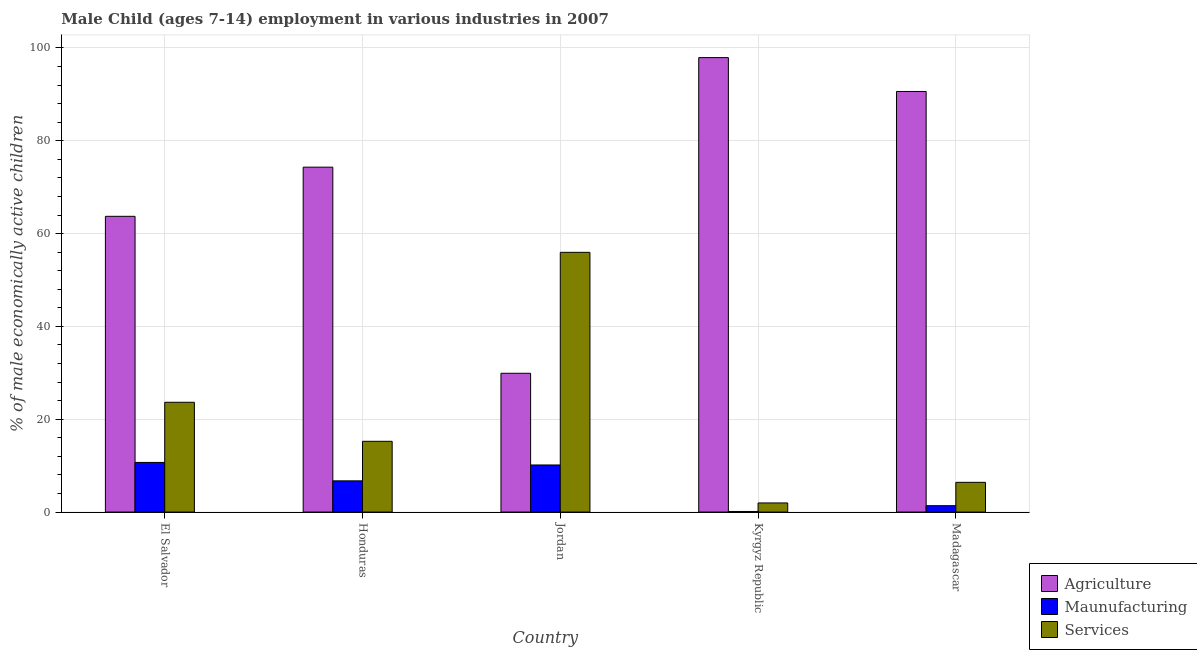How many different coloured bars are there?
Your answer should be very brief. 3. How many groups of bars are there?
Your response must be concise. 5. Are the number of bars per tick equal to the number of legend labels?
Provide a succinct answer. Yes. What is the label of the 5th group of bars from the left?
Your answer should be very brief. Madagascar. In how many cases, is the number of bars for a given country not equal to the number of legend labels?
Provide a succinct answer. 0. What is the percentage of economically active children in services in El Salvador?
Offer a terse response. 23.65. Across all countries, what is the maximum percentage of economically active children in agriculture?
Your answer should be very brief. 97.92. Across all countries, what is the minimum percentage of economically active children in agriculture?
Keep it short and to the point. 29.9. In which country was the percentage of economically active children in agriculture maximum?
Your answer should be compact. Kyrgyz Republic. In which country was the percentage of economically active children in agriculture minimum?
Offer a terse response. Jordan. What is the total percentage of economically active children in manufacturing in the graph?
Keep it short and to the point. 29.04. What is the difference between the percentage of economically active children in agriculture in Honduras and that in Jordan?
Ensure brevity in your answer.  44.41. What is the difference between the percentage of economically active children in manufacturing in Madagascar and the percentage of economically active children in agriculture in El Salvador?
Your answer should be very brief. -62.35. What is the average percentage of economically active children in services per country?
Offer a very short reply. 20.64. What is the difference between the percentage of economically active children in agriculture and percentage of economically active children in manufacturing in Jordan?
Provide a short and direct response. 19.76. In how many countries, is the percentage of economically active children in agriculture greater than 84 %?
Provide a succinct answer. 2. What is the ratio of the percentage of economically active children in manufacturing in El Salvador to that in Jordan?
Make the answer very short. 1.05. Is the percentage of economically active children in services in Jordan less than that in Kyrgyz Republic?
Your answer should be compact. No. Is the difference between the percentage of economically active children in agriculture in El Salvador and Jordan greater than the difference between the percentage of economically active children in services in El Salvador and Jordan?
Make the answer very short. Yes. What is the difference between the highest and the second highest percentage of economically active children in services?
Make the answer very short. 32.31. What is the difference between the highest and the lowest percentage of economically active children in manufacturing?
Offer a very short reply. 10.57. In how many countries, is the percentage of economically active children in services greater than the average percentage of economically active children in services taken over all countries?
Give a very brief answer. 2. What does the 1st bar from the left in El Salvador represents?
Your answer should be very brief. Agriculture. What does the 3rd bar from the right in Honduras represents?
Your answer should be very brief. Agriculture. Is it the case that in every country, the sum of the percentage of economically active children in agriculture and percentage of economically active children in manufacturing is greater than the percentage of economically active children in services?
Keep it short and to the point. No. Are the values on the major ticks of Y-axis written in scientific E-notation?
Ensure brevity in your answer.  No. Where does the legend appear in the graph?
Your answer should be very brief. Bottom right. How are the legend labels stacked?
Provide a short and direct response. Vertical. What is the title of the graph?
Your response must be concise. Male Child (ages 7-14) employment in various industries in 2007. Does "Machinery" appear as one of the legend labels in the graph?
Provide a succinct answer. No. What is the label or title of the X-axis?
Your answer should be compact. Country. What is the label or title of the Y-axis?
Offer a terse response. % of male economically active children. What is the % of male economically active children in Agriculture in El Salvador?
Your answer should be very brief. 63.72. What is the % of male economically active children of Maunufacturing in El Salvador?
Make the answer very short. 10.69. What is the % of male economically active children of Services in El Salvador?
Offer a terse response. 23.65. What is the % of male economically active children in Agriculture in Honduras?
Ensure brevity in your answer.  74.31. What is the % of male economically active children in Maunufacturing in Honduras?
Provide a short and direct response. 6.72. What is the % of male economically active children in Services in Honduras?
Ensure brevity in your answer.  15.24. What is the % of male economically active children of Agriculture in Jordan?
Your answer should be very brief. 29.9. What is the % of male economically active children of Maunufacturing in Jordan?
Make the answer very short. 10.14. What is the % of male economically active children in Services in Jordan?
Make the answer very short. 55.96. What is the % of male economically active children in Agriculture in Kyrgyz Republic?
Provide a short and direct response. 97.92. What is the % of male economically active children in Maunufacturing in Kyrgyz Republic?
Offer a terse response. 0.12. What is the % of male economically active children of Services in Kyrgyz Republic?
Provide a succinct answer. 1.96. What is the % of male economically active children of Agriculture in Madagascar?
Give a very brief answer. 90.62. What is the % of male economically active children of Maunufacturing in Madagascar?
Your response must be concise. 1.37. What is the % of male economically active children in Services in Madagascar?
Your response must be concise. 6.4. Across all countries, what is the maximum % of male economically active children of Agriculture?
Provide a short and direct response. 97.92. Across all countries, what is the maximum % of male economically active children in Maunufacturing?
Your response must be concise. 10.69. Across all countries, what is the maximum % of male economically active children of Services?
Make the answer very short. 55.96. Across all countries, what is the minimum % of male economically active children in Agriculture?
Keep it short and to the point. 29.9. Across all countries, what is the minimum % of male economically active children of Maunufacturing?
Your answer should be very brief. 0.12. Across all countries, what is the minimum % of male economically active children of Services?
Your answer should be compact. 1.96. What is the total % of male economically active children in Agriculture in the graph?
Give a very brief answer. 356.47. What is the total % of male economically active children of Maunufacturing in the graph?
Provide a short and direct response. 29.04. What is the total % of male economically active children of Services in the graph?
Keep it short and to the point. 103.21. What is the difference between the % of male economically active children of Agriculture in El Salvador and that in Honduras?
Offer a terse response. -10.59. What is the difference between the % of male economically active children in Maunufacturing in El Salvador and that in Honduras?
Give a very brief answer. 3.97. What is the difference between the % of male economically active children of Services in El Salvador and that in Honduras?
Offer a very short reply. 8.41. What is the difference between the % of male economically active children in Agriculture in El Salvador and that in Jordan?
Your answer should be compact. 33.82. What is the difference between the % of male economically active children of Maunufacturing in El Salvador and that in Jordan?
Your answer should be compact. 0.55. What is the difference between the % of male economically active children in Services in El Salvador and that in Jordan?
Your answer should be compact. -32.31. What is the difference between the % of male economically active children of Agriculture in El Salvador and that in Kyrgyz Republic?
Your answer should be very brief. -34.2. What is the difference between the % of male economically active children of Maunufacturing in El Salvador and that in Kyrgyz Republic?
Your answer should be very brief. 10.57. What is the difference between the % of male economically active children of Services in El Salvador and that in Kyrgyz Republic?
Offer a terse response. 21.69. What is the difference between the % of male economically active children of Agriculture in El Salvador and that in Madagascar?
Your response must be concise. -26.9. What is the difference between the % of male economically active children in Maunufacturing in El Salvador and that in Madagascar?
Give a very brief answer. 9.32. What is the difference between the % of male economically active children of Services in El Salvador and that in Madagascar?
Keep it short and to the point. 17.25. What is the difference between the % of male economically active children of Agriculture in Honduras and that in Jordan?
Your answer should be compact. 44.41. What is the difference between the % of male economically active children of Maunufacturing in Honduras and that in Jordan?
Give a very brief answer. -3.42. What is the difference between the % of male economically active children of Services in Honduras and that in Jordan?
Your answer should be very brief. -40.72. What is the difference between the % of male economically active children of Agriculture in Honduras and that in Kyrgyz Republic?
Give a very brief answer. -23.61. What is the difference between the % of male economically active children of Maunufacturing in Honduras and that in Kyrgyz Republic?
Give a very brief answer. 6.6. What is the difference between the % of male economically active children of Services in Honduras and that in Kyrgyz Republic?
Your answer should be compact. 13.28. What is the difference between the % of male economically active children of Agriculture in Honduras and that in Madagascar?
Ensure brevity in your answer.  -16.31. What is the difference between the % of male economically active children in Maunufacturing in Honduras and that in Madagascar?
Keep it short and to the point. 5.35. What is the difference between the % of male economically active children of Services in Honduras and that in Madagascar?
Ensure brevity in your answer.  8.84. What is the difference between the % of male economically active children of Agriculture in Jordan and that in Kyrgyz Republic?
Give a very brief answer. -68.02. What is the difference between the % of male economically active children in Maunufacturing in Jordan and that in Kyrgyz Republic?
Offer a very short reply. 10.02. What is the difference between the % of male economically active children of Agriculture in Jordan and that in Madagascar?
Give a very brief answer. -60.72. What is the difference between the % of male economically active children in Maunufacturing in Jordan and that in Madagascar?
Offer a terse response. 8.77. What is the difference between the % of male economically active children of Services in Jordan and that in Madagascar?
Your response must be concise. 49.56. What is the difference between the % of male economically active children in Maunufacturing in Kyrgyz Republic and that in Madagascar?
Your answer should be compact. -1.25. What is the difference between the % of male economically active children in Services in Kyrgyz Republic and that in Madagascar?
Offer a very short reply. -4.44. What is the difference between the % of male economically active children in Agriculture in El Salvador and the % of male economically active children in Maunufacturing in Honduras?
Give a very brief answer. 57. What is the difference between the % of male economically active children of Agriculture in El Salvador and the % of male economically active children of Services in Honduras?
Your response must be concise. 48.48. What is the difference between the % of male economically active children of Maunufacturing in El Salvador and the % of male economically active children of Services in Honduras?
Offer a very short reply. -4.55. What is the difference between the % of male economically active children in Agriculture in El Salvador and the % of male economically active children in Maunufacturing in Jordan?
Offer a very short reply. 53.58. What is the difference between the % of male economically active children of Agriculture in El Salvador and the % of male economically active children of Services in Jordan?
Your answer should be very brief. 7.76. What is the difference between the % of male economically active children in Maunufacturing in El Salvador and the % of male economically active children in Services in Jordan?
Offer a terse response. -45.27. What is the difference between the % of male economically active children of Agriculture in El Salvador and the % of male economically active children of Maunufacturing in Kyrgyz Republic?
Provide a short and direct response. 63.6. What is the difference between the % of male economically active children in Agriculture in El Salvador and the % of male economically active children in Services in Kyrgyz Republic?
Make the answer very short. 61.76. What is the difference between the % of male economically active children of Maunufacturing in El Salvador and the % of male economically active children of Services in Kyrgyz Republic?
Provide a succinct answer. 8.73. What is the difference between the % of male economically active children in Agriculture in El Salvador and the % of male economically active children in Maunufacturing in Madagascar?
Give a very brief answer. 62.35. What is the difference between the % of male economically active children of Agriculture in El Salvador and the % of male economically active children of Services in Madagascar?
Give a very brief answer. 57.32. What is the difference between the % of male economically active children in Maunufacturing in El Salvador and the % of male economically active children in Services in Madagascar?
Provide a succinct answer. 4.29. What is the difference between the % of male economically active children in Agriculture in Honduras and the % of male economically active children in Maunufacturing in Jordan?
Provide a short and direct response. 64.17. What is the difference between the % of male economically active children of Agriculture in Honduras and the % of male economically active children of Services in Jordan?
Make the answer very short. 18.35. What is the difference between the % of male economically active children of Maunufacturing in Honduras and the % of male economically active children of Services in Jordan?
Make the answer very short. -49.24. What is the difference between the % of male economically active children of Agriculture in Honduras and the % of male economically active children of Maunufacturing in Kyrgyz Republic?
Give a very brief answer. 74.19. What is the difference between the % of male economically active children in Agriculture in Honduras and the % of male economically active children in Services in Kyrgyz Republic?
Your answer should be very brief. 72.35. What is the difference between the % of male economically active children of Maunufacturing in Honduras and the % of male economically active children of Services in Kyrgyz Republic?
Provide a short and direct response. 4.76. What is the difference between the % of male economically active children in Agriculture in Honduras and the % of male economically active children in Maunufacturing in Madagascar?
Keep it short and to the point. 72.94. What is the difference between the % of male economically active children of Agriculture in Honduras and the % of male economically active children of Services in Madagascar?
Your answer should be compact. 67.91. What is the difference between the % of male economically active children in Maunufacturing in Honduras and the % of male economically active children in Services in Madagascar?
Keep it short and to the point. 0.32. What is the difference between the % of male economically active children of Agriculture in Jordan and the % of male economically active children of Maunufacturing in Kyrgyz Republic?
Provide a short and direct response. 29.78. What is the difference between the % of male economically active children in Agriculture in Jordan and the % of male economically active children in Services in Kyrgyz Republic?
Provide a succinct answer. 27.94. What is the difference between the % of male economically active children in Maunufacturing in Jordan and the % of male economically active children in Services in Kyrgyz Republic?
Make the answer very short. 8.18. What is the difference between the % of male economically active children in Agriculture in Jordan and the % of male economically active children in Maunufacturing in Madagascar?
Offer a very short reply. 28.53. What is the difference between the % of male economically active children in Maunufacturing in Jordan and the % of male economically active children in Services in Madagascar?
Ensure brevity in your answer.  3.74. What is the difference between the % of male economically active children in Agriculture in Kyrgyz Republic and the % of male economically active children in Maunufacturing in Madagascar?
Your answer should be compact. 96.55. What is the difference between the % of male economically active children in Agriculture in Kyrgyz Republic and the % of male economically active children in Services in Madagascar?
Provide a short and direct response. 91.52. What is the difference between the % of male economically active children in Maunufacturing in Kyrgyz Republic and the % of male economically active children in Services in Madagascar?
Give a very brief answer. -6.28. What is the average % of male economically active children of Agriculture per country?
Offer a terse response. 71.29. What is the average % of male economically active children of Maunufacturing per country?
Your answer should be very brief. 5.81. What is the average % of male economically active children in Services per country?
Provide a short and direct response. 20.64. What is the difference between the % of male economically active children of Agriculture and % of male economically active children of Maunufacturing in El Salvador?
Give a very brief answer. 53.03. What is the difference between the % of male economically active children in Agriculture and % of male economically active children in Services in El Salvador?
Provide a short and direct response. 40.07. What is the difference between the % of male economically active children of Maunufacturing and % of male economically active children of Services in El Salvador?
Provide a short and direct response. -12.96. What is the difference between the % of male economically active children of Agriculture and % of male economically active children of Maunufacturing in Honduras?
Give a very brief answer. 67.59. What is the difference between the % of male economically active children in Agriculture and % of male economically active children in Services in Honduras?
Your answer should be very brief. 59.07. What is the difference between the % of male economically active children in Maunufacturing and % of male economically active children in Services in Honduras?
Provide a short and direct response. -8.52. What is the difference between the % of male economically active children in Agriculture and % of male economically active children in Maunufacturing in Jordan?
Keep it short and to the point. 19.76. What is the difference between the % of male economically active children in Agriculture and % of male economically active children in Services in Jordan?
Ensure brevity in your answer.  -26.06. What is the difference between the % of male economically active children in Maunufacturing and % of male economically active children in Services in Jordan?
Give a very brief answer. -45.82. What is the difference between the % of male economically active children of Agriculture and % of male economically active children of Maunufacturing in Kyrgyz Republic?
Your answer should be very brief. 97.8. What is the difference between the % of male economically active children of Agriculture and % of male economically active children of Services in Kyrgyz Republic?
Give a very brief answer. 95.96. What is the difference between the % of male economically active children in Maunufacturing and % of male economically active children in Services in Kyrgyz Republic?
Make the answer very short. -1.84. What is the difference between the % of male economically active children of Agriculture and % of male economically active children of Maunufacturing in Madagascar?
Give a very brief answer. 89.25. What is the difference between the % of male economically active children in Agriculture and % of male economically active children in Services in Madagascar?
Offer a very short reply. 84.22. What is the difference between the % of male economically active children in Maunufacturing and % of male economically active children in Services in Madagascar?
Offer a terse response. -5.03. What is the ratio of the % of male economically active children in Agriculture in El Salvador to that in Honduras?
Offer a terse response. 0.86. What is the ratio of the % of male economically active children in Maunufacturing in El Salvador to that in Honduras?
Your response must be concise. 1.59. What is the ratio of the % of male economically active children in Services in El Salvador to that in Honduras?
Your answer should be very brief. 1.55. What is the ratio of the % of male economically active children in Agriculture in El Salvador to that in Jordan?
Offer a very short reply. 2.13. What is the ratio of the % of male economically active children of Maunufacturing in El Salvador to that in Jordan?
Ensure brevity in your answer.  1.05. What is the ratio of the % of male economically active children of Services in El Salvador to that in Jordan?
Ensure brevity in your answer.  0.42. What is the ratio of the % of male economically active children of Agriculture in El Salvador to that in Kyrgyz Republic?
Keep it short and to the point. 0.65. What is the ratio of the % of male economically active children in Maunufacturing in El Salvador to that in Kyrgyz Republic?
Your response must be concise. 89.08. What is the ratio of the % of male economically active children of Services in El Salvador to that in Kyrgyz Republic?
Your answer should be very brief. 12.07. What is the ratio of the % of male economically active children in Agriculture in El Salvador to that in Madagascar?
Your response must be concise. 0.7. What is the ratio of the % of male economically active children in Maunufacturing in El Salvador to that in Madagascar?
Make the answer very short. 7.8. What is the ratio of the % of male economically active children of Services in El Salvador to that in Madagascar?
Ensure brevity in your answer.  3.7. What is the ratio of the % of male economically active children of Agriculture in Honduras to that in Jordan?
Offer a terse response. 2.49. What is the ratio of the % of male economically active children of Maunufacturing in Honduras to that in Jordan?
Offer a very short reply. 0.66. What is the ratio of the % of male economically active children of Services in Honduras to that in Jordan?
Provide a succinct answer. 0.27. What is the ratio of the % of male economically active children in Agriculture in Honduras to that in Kyrgyz Republic?
Offer a very short reply. 0.76. What is the ratio of the % of male economically active children in Maunufacturing in Honduras to that in Kyrgyz Republic?
Provide a short and direct response. 56. What is the ratio of the % of male economically active children of Services in Honduras to that in Kyrgyz Republic?
Your response must be concise. 7.78. What is the ratio of the % of male economically active children in Agriculture in Honduras to that in Madagascar?
Provide a succinct answer. 0.82. What is the ratio of the % of male economically active children of Maunufacturing in Honduras to that in Madagascar?
Your answer should be compact. 4.91. What is the ratio of the % of male economically active children of Services in Honduras to that in Madagascar?
Your response must be concise. 2.38. What is the ratio of the % of male economically active children of Agriculture in Jordan to that in Kyrgyz Republic?
Provide a succinct answer. 0.31. What is the ratio of the % of male economically active children of Maunufacturing in Jordan to that in Kyrgyz Republic?
Offer a terse response. 84.5. What is the ratio of the % of male economically active children of Services in Jordan to that in Kyrgyz Republic?
Your answer should be compact. 28.55. What is the ratio of the % of male economically active children in Agriculture in Jordan to that in Madagascar?
Give a very brief answer. 0.33. What is the ratio of the % of male economically active children of Maunufacturing in Jordan to that in Madagascar?
Your answer should be very brief. 7.4. What is the ratio of the % of male economically active children of Services in Jordan to that in Madagascar?
Provide a succinct answer. 8.74. What is the ratio of the % of male economically active children of Agriculture in Kyrgyz Republic to that in Madagascar?
Your answer should be compact. 1.08. What is the ratio of the % of male economically active children in Maunufacturing in Kyrgyz Republic to that in Madagascar?
Give a very brief answer. 0.09. What is the ratio of the % of male economically active children in Services in Kyrgyz Republic to that in Madagascar?
Provide a succinct answer. 0.31. What is the difference between the highest and the second highest % of male economically active children in Agriculture?
Provide a short and direct response. 7.3. What is the difference between the highest and the second highest % of male economically active children in Maunufacturing?
Your response must be concise. 0.55. What is the difference between the highest and the second highest % of male economically active children of Services?
Your response must be concise. 32.31. What is the difference between the highest and the lowest % of male economically active children in Agriculture?
Your answer should be compact. 68.02. What is the difference between the highest and the lowest % of male economically active children in Maunufacturing?
Offer a terse response. 10.57. 